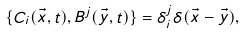Convert formula to latex. <formula><loc_0><loc_0><loc_500><loc_500>\{ C _ { i } ( \vec { x } , t ) , B ^ { j } ( \vec { y } , t ) \} = \delta _ { i } ^ { j } \delta ( \vec { x } - \vec { y } ) ,</formula> 